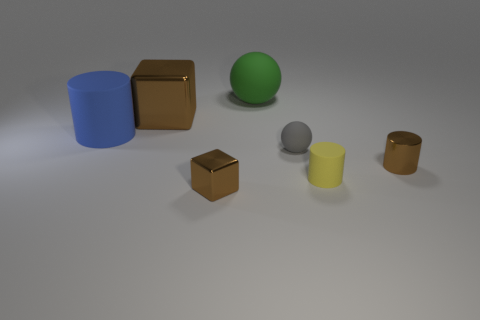Add 1 cylinders. How many objects exist? 8 Subtract all spheres. How many objects are left? 5 Subtract 0 purple cubes. How many objects are left? 7 Subtract all yellow rubber cylinders. Subtract all tiny brown metallic blocks. How many objects are left? 5 Add 1 small rubber cylinders. How many small rubber cylinders are left? 2 Add 4 large cyan shiny spheres. How many large cyan shiny spheres exist? 4 